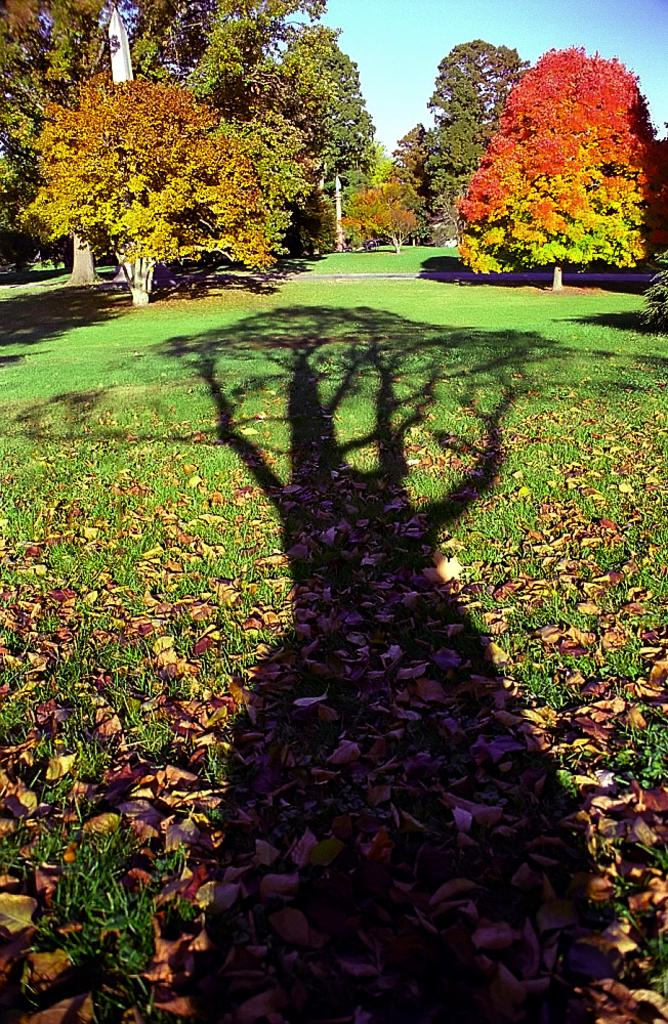What can be seen on the ground in the image? There is a shadow of a tree on the ground. What is covering the ground? The ground is covered with dry leaves and grass. What is visible in the background of the image? There are trees visible in the background. How would you describe the sky in the image? The sky is clear in the image. How many apples are hanging from the tree in the image? There are no apples visible in the image; it only shows a shadow of a tree on the ground. Is there a letter addressed to someone in the image? There is no letter present in the image. 